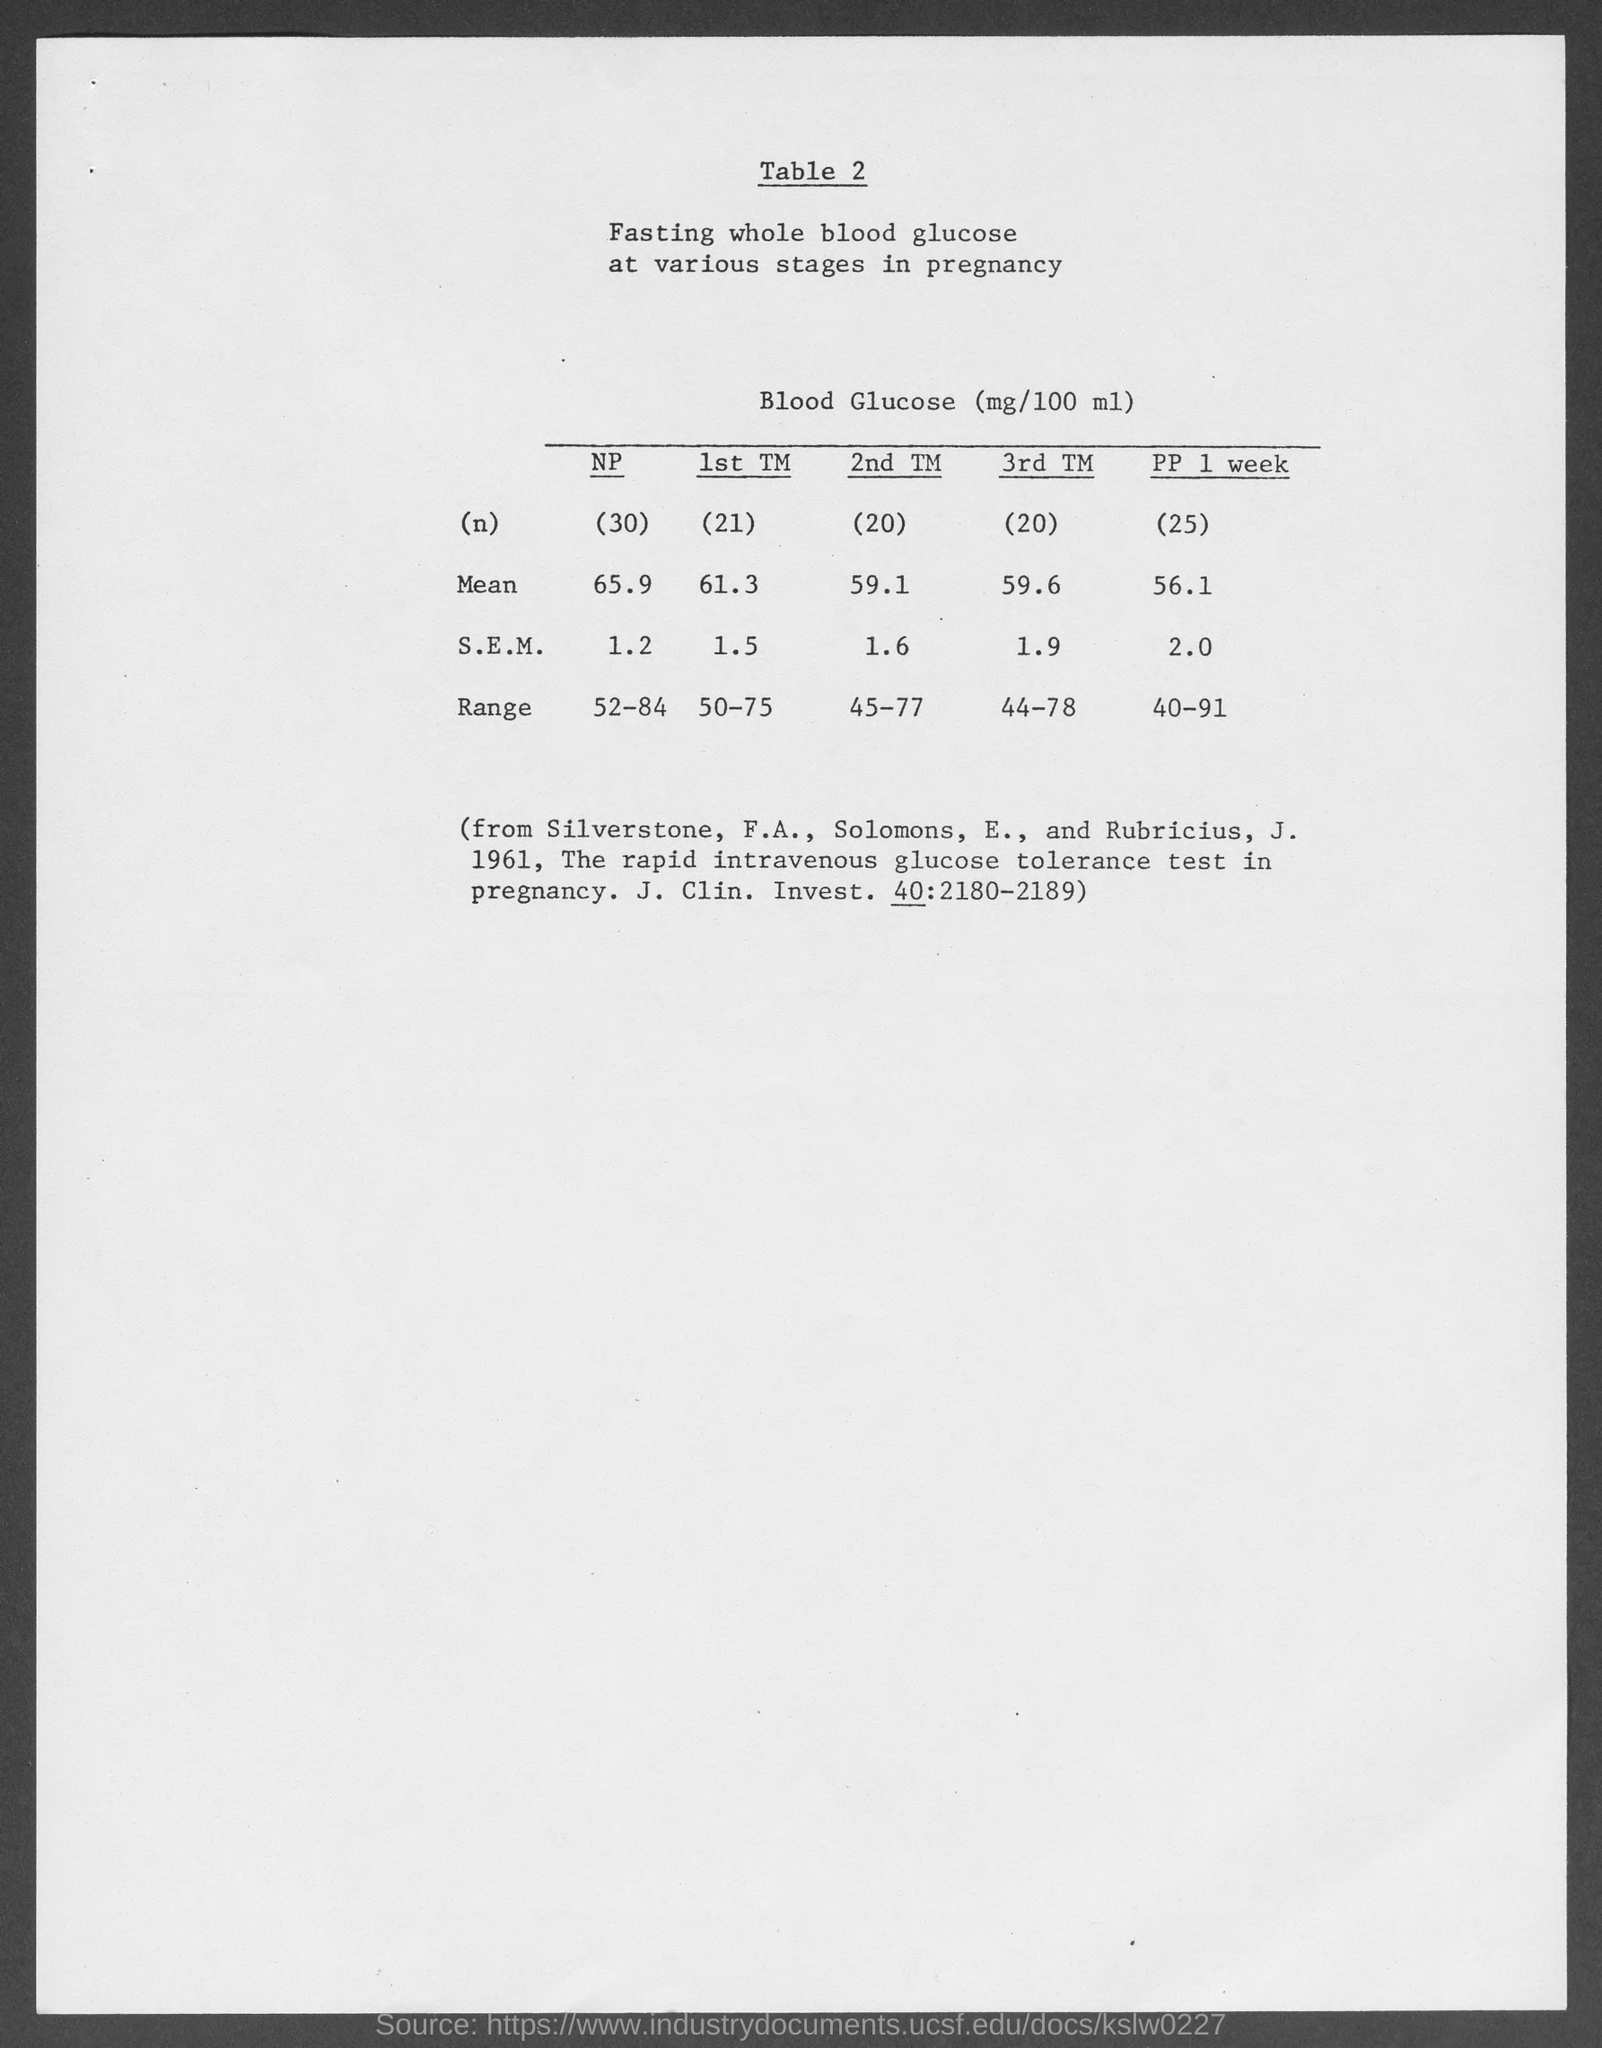Outline some significant characteristics in this image. The second median of the data set is 1.6. The mean value of the third TM is 59.6. The mean value of the first TM is 61.3. 